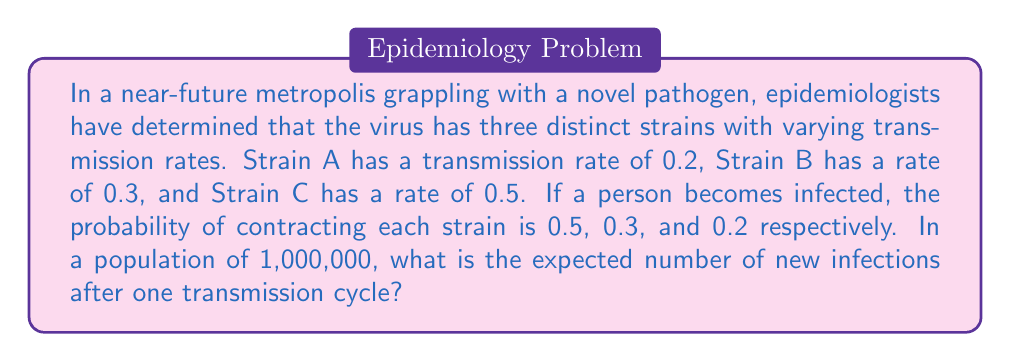Can you answer this question? To solve this problem, we need to use the concept of expected value for a discrete random variable. Let's approach this step-by-step:

1) First, let's define our random variable X as the number of new infections per person.

2) We have three possible outcomes (strains) with different probabilities and transmission rates:

   Strain A: P(A) = 0.5, transmission rate = 0.2
   Strain B: P(B) = 0.3, transmission rate = 0.3
   Strain C: P(C) = 0.2, transmission rate = 0.5

3) The expected value of X is given by:

   $$E(X) = \sum_{i} x_i \cdot P(X = x_i)$$

   Where $x_i$ are the possible values of X (in this case, the transmission rates), and P(X = $x_i$) are their respective probabilities.

4) Substituting our values:

   $$E(X) = 0.2 \cdot 0.5 + 0.3 \cdot 0.3 + 0.5 \cdot 0.2$$

5) Calculating:

   $$E(X) = 0.1 + 0.09 + 0.1 = 0.29$$

6) This means that, on average, each infected person will infect 0.29 new people in one transmission cycle.

7) To find the expected number of new infections in a population of 1,000,000, we multiply E(X) by the population size:

   $$\text{Expected new infections} = E(X) \cdot 1,000,000 = 0.29 \cdot 1,000,000 = 290,000$$

Therefore, after one transmission cycle, we expect 290,000 new infections in the city.
Answer: 290,000 new infections 